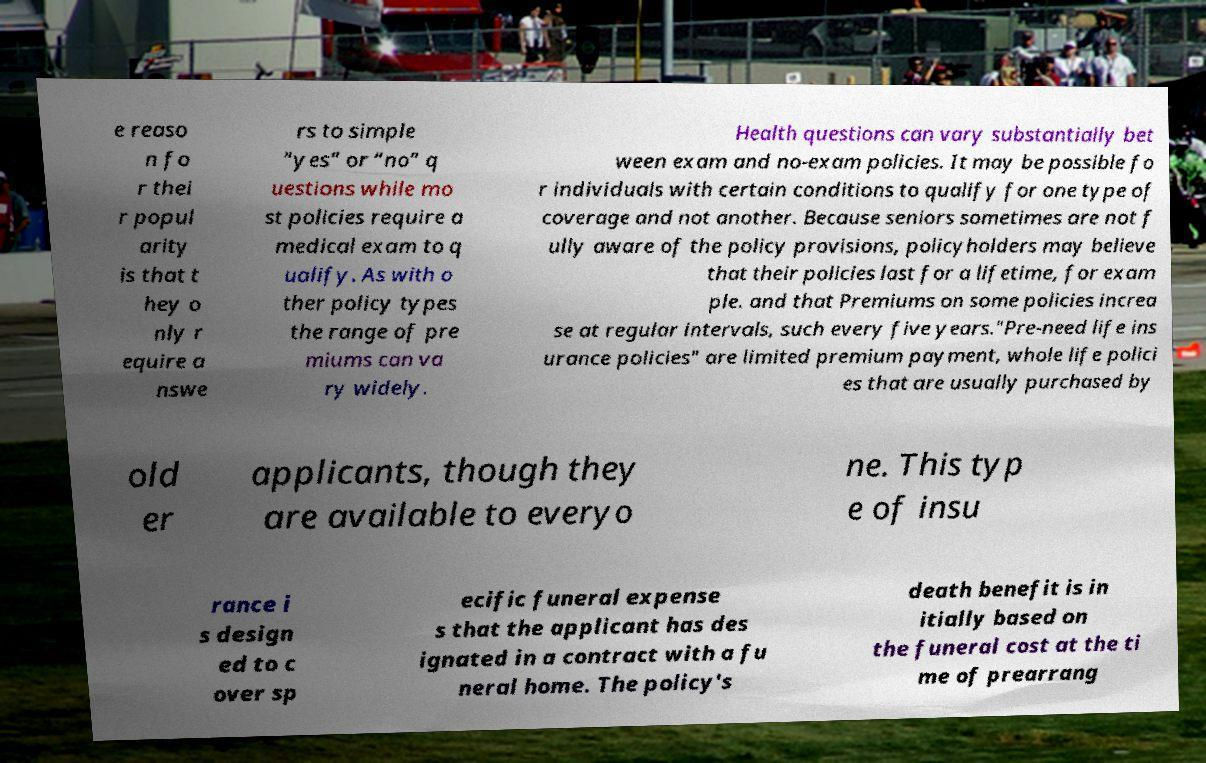Could you extract and type out the text from this image? e reaso n fo r thei r popul arity is that t hey o nly r equire a nswe rs to simple “yes” or “no” q uestions while mo st policies require a medical exam to q ualify. As with o ther policy types the range of pre miums can va ry widely. Health questions can vary substantially bet ween exam and no-exam policies. It may be possible fo r individuals with certain conditions to qualify for one type of coverage and not another. Because seniors sometimes are not f ully aware of the policy provisions, policyholders may believe that their policies last for a lifetime, for exam ple. and that Premiums on some policies increa se at regular intervals, such every five years."Pre-need life ins urance policies" are limited premium payment, whole life polici es that are usually purchased by old er applicants, though they are available to everyo ne. This typ e of insu rance i s design ed to c over sp ecific funeral expense s that the applicant has des ignated in a contract with a fu neral home. The policy's death benefit is in itially based on the funeral cost at the ti me of prearrang 